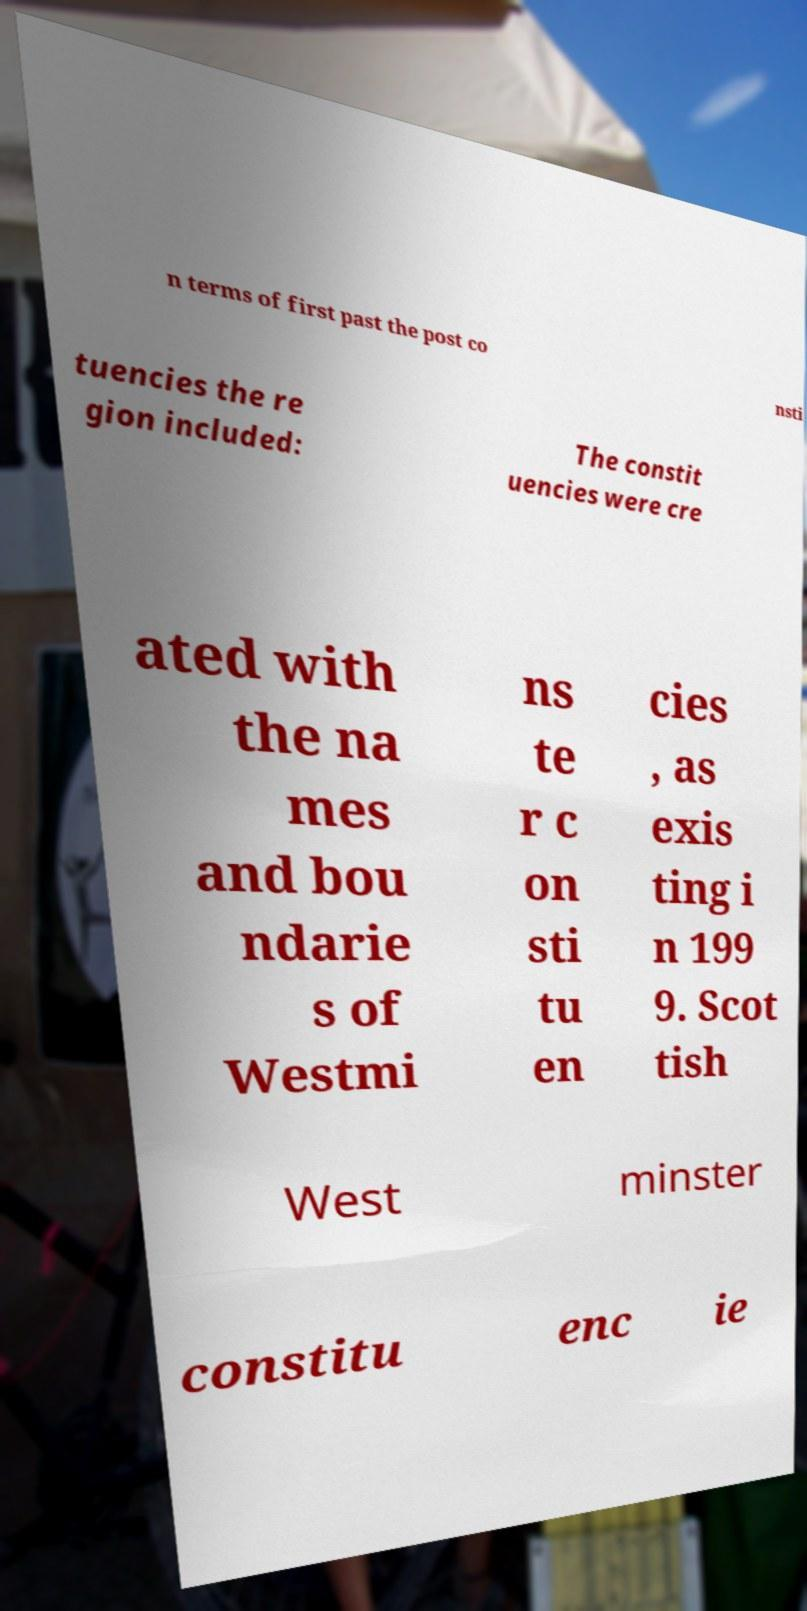Could you assist in decoding the text presented in this image and type it out clearly? n terms of first past the post co nsti tuencies the re gion included: The constit uencies were cre ated with the na mes and bou ndarie s of Westmi ns te r c on sti tu en cies , as exis ting i n 199 9. Scot tish West minster constitu enc ie 